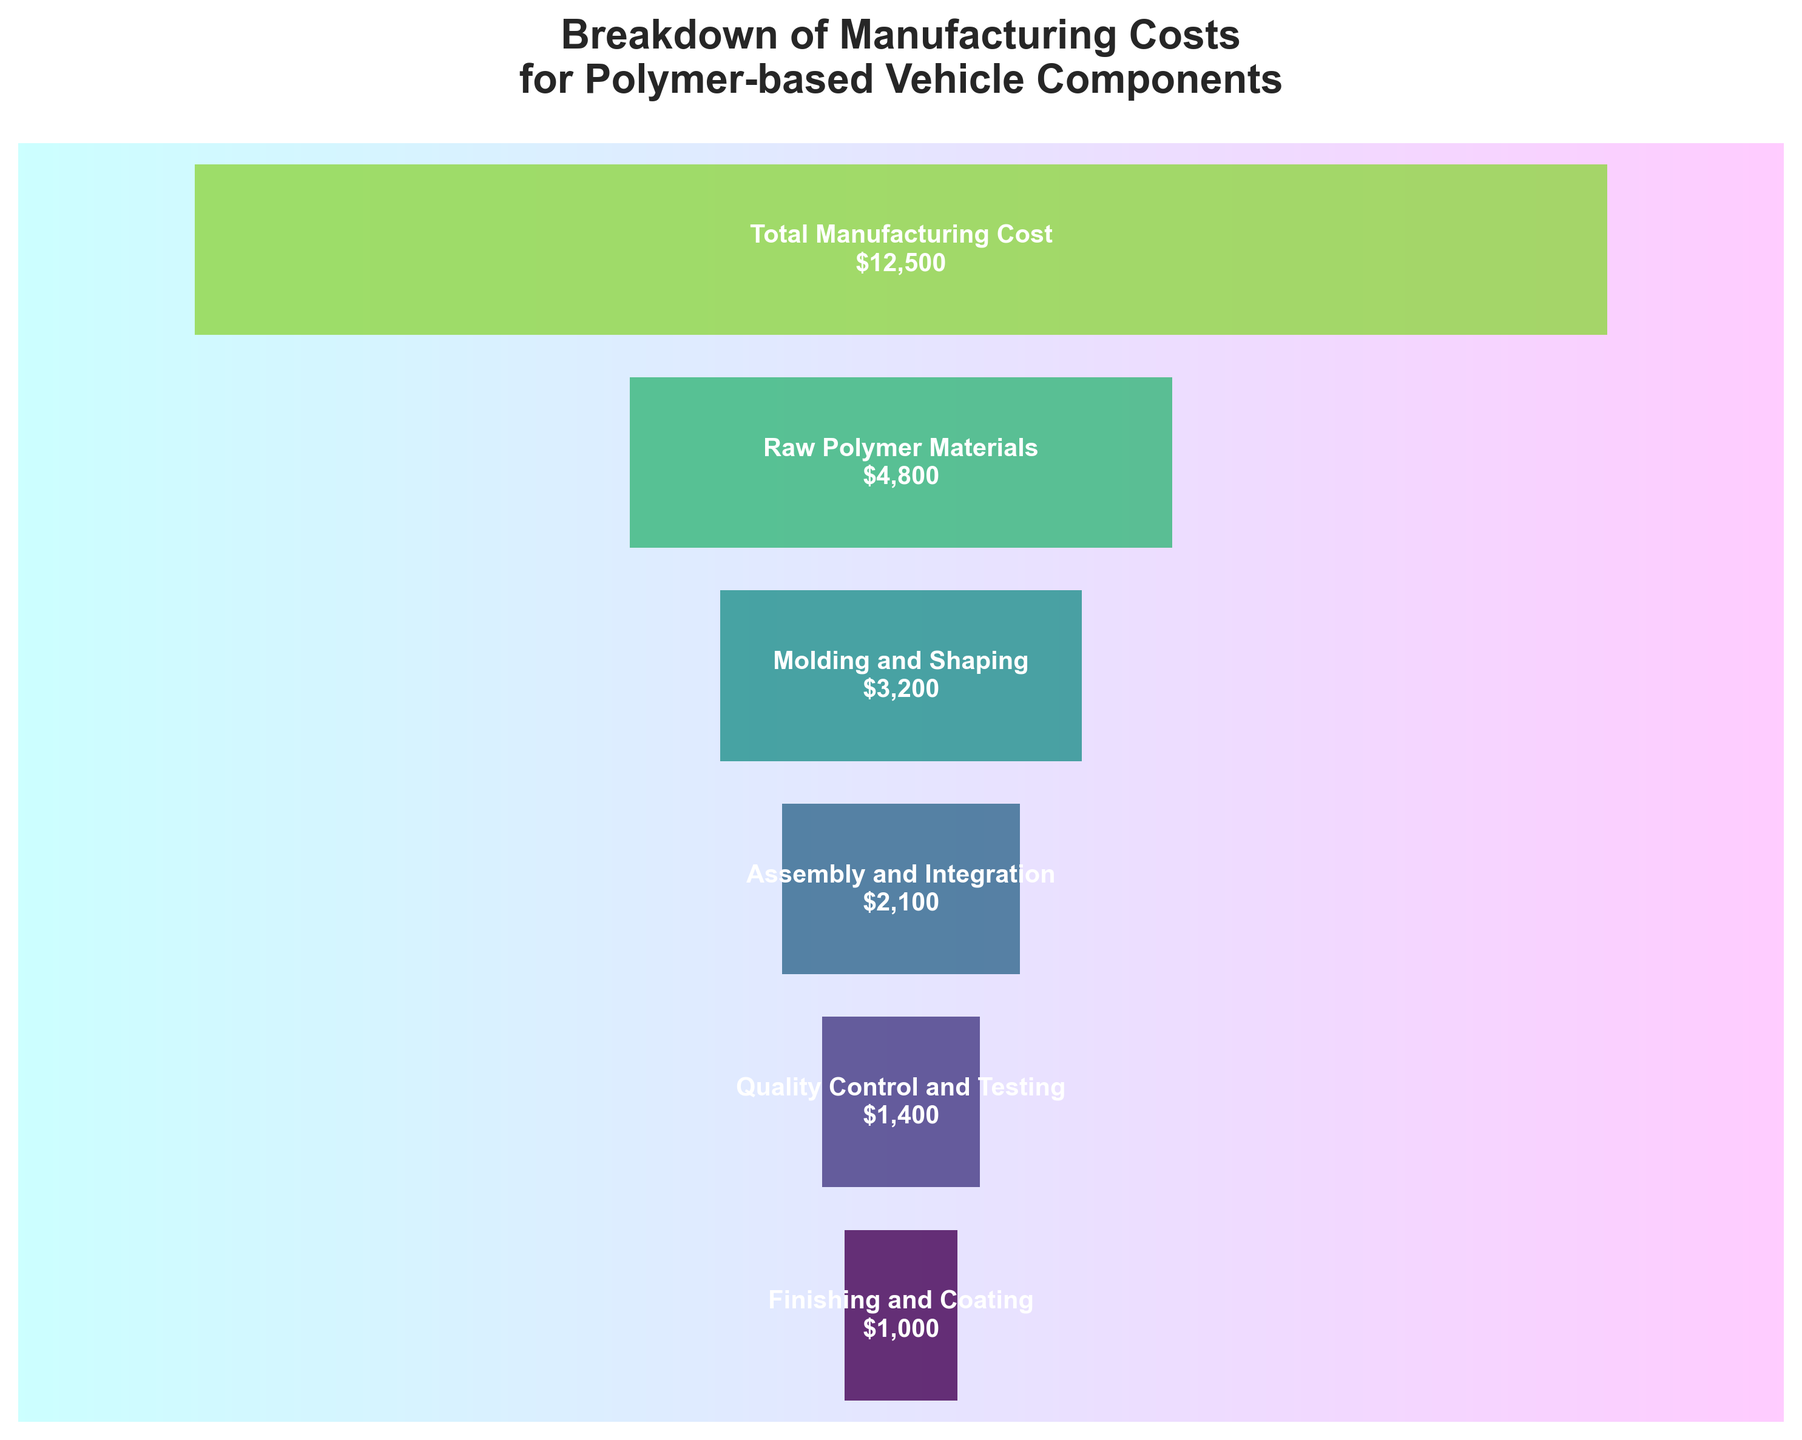How much does the Quality Control and Testing stage cost? The figure shows the cost for each stage. Look for the bar labeled "Quality Control and Testing" and note the cost.
Answer: $1,400 What is the total cost for Raw Polymer Materials and Molding and Shaping stages combined? Refer to the figure for the costs of "Raw Polymer Materials" and "Molding and Shaping." Add $4,800 and $3,200 together.
Answer: $8,000 Which stage has the least cost, and what is it? Scan the figure for the smallest bar, labeled "Finishing and Coating," and note the cost.
Answer: Finishing and Coating, $1,000 What percentage of the total manufacturing cost is attributed to Assembly and Integration? Look for the cost of "Assembly and Integration" ($2,100) and the "Total Manufacturing Cost" ($12,500). Calculate the percentage: \((2100 / 12500) \times 100\).
Answer: 16.8% How does the cost of Molding and Shaping compare to the cost of Quality Control and Testing? Note the costs of "Molding and Shaping" ($3,200) and "Quality Control and Testing" ($1,400). Compare by subtraction: \(3200 - 1400 = 1800\).
Answer: $1,800 more Which stage comes after Raw Polymer Materials in terms of cost? Refer to the funnel chart. The stage immediately below "Raw Polymer Materials" is "Molding and Shaping."
Answer: Molding and Shaping What is the ratio of the cost of Raw Polymer Materials to the cost of Assembly and Integration? Find the costs of "Raw Polymer Materials" ($4,800) and "Assembly and Integration" ($2,100). Calculate the ratio: \(4800 / 2100\).
Answer: 2.29 Is the cost of Finishing and Coating less than or more than half the cost of Molding and Shaping? Check the costs of "Finishing and Coating" ($1,000) and "Molding and Shaping" ($3,200). Compare half of $3,200 (\(3200 / 2 = 1600\)) with $1,000.
Answer: Less What overall trend in cost reduction does the funnel chart show from top to bottom? Observe the funnel chart from top ("Total Manufacturing Cost") to bottom ("Finishing and Coating"). Notice how the costs decrease progressively.
Answer: Decreasing How much more expensive is the Assembly and Integration stage compared to the Finishing and Coating stage? Look at the costs: "Assembly and Integration" ($2,100) and "Finishing and Coating" ($1,000). Subtract: \(2100 - 1000\).
Answer: $1,100 